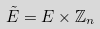<formula> <loc_0><loc_0><loc_500><loc_500>\tilde { E } = E \times \mathbb { Z } _ { n }</formula> 